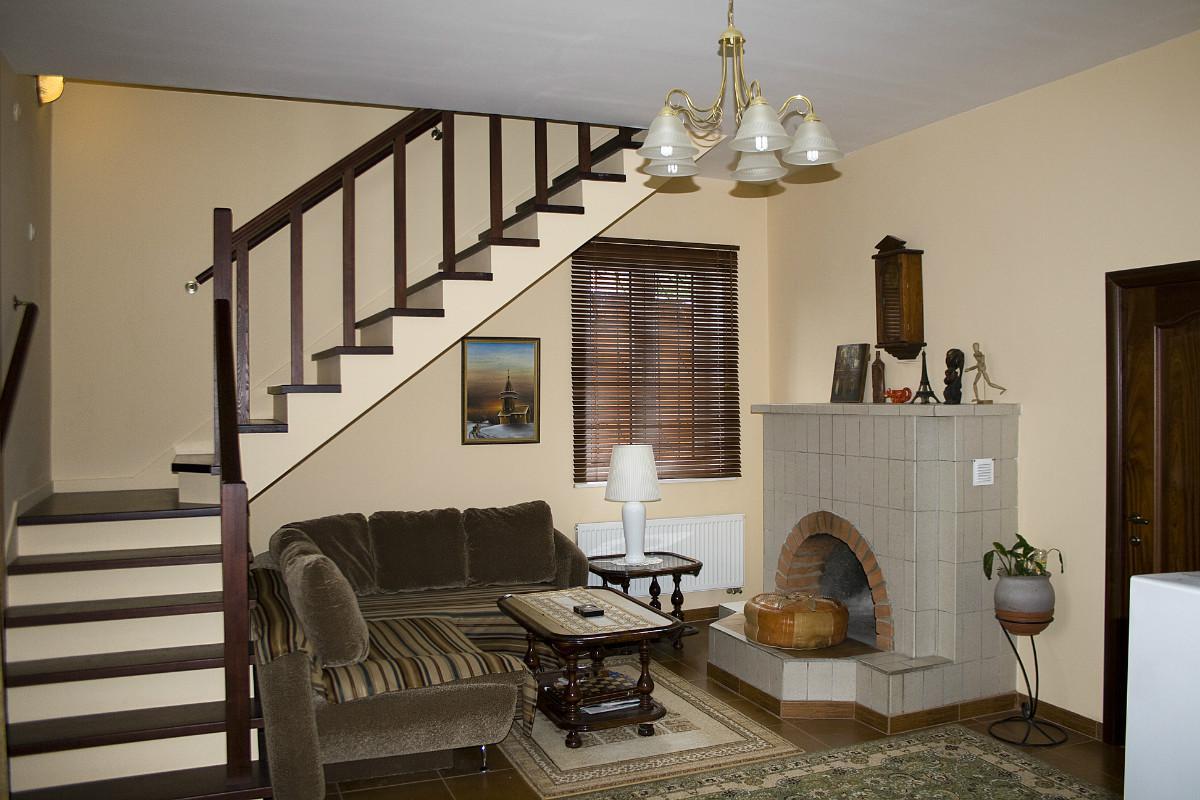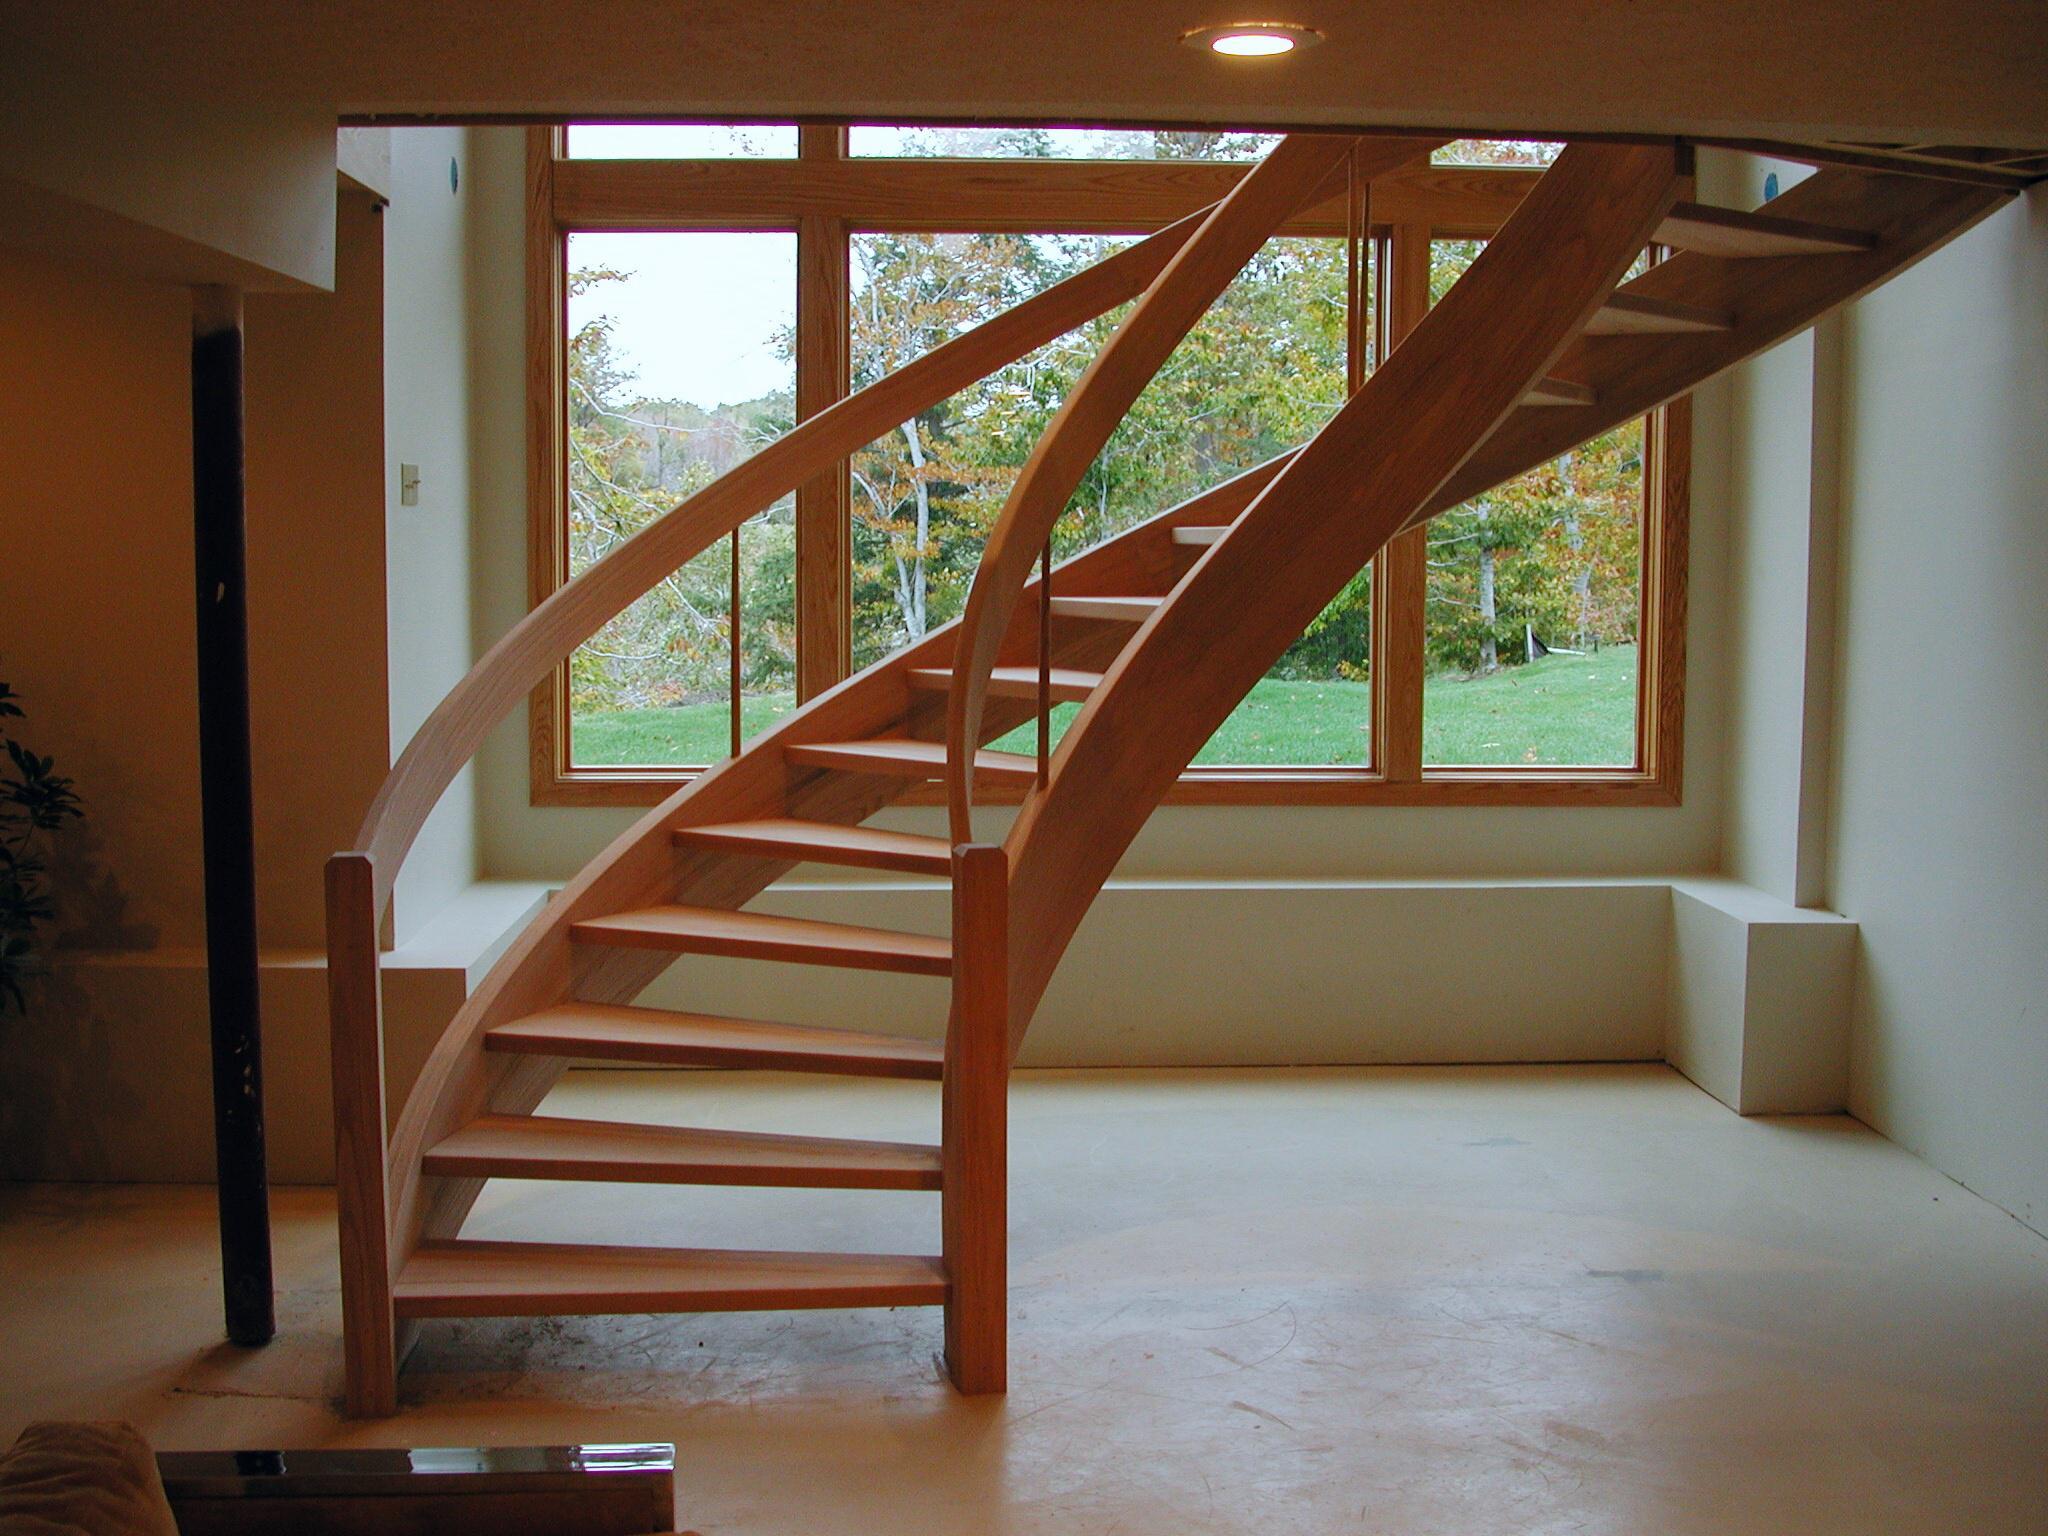The first image is the image on the left, the second image is the image on the right. Analyze the images presented: Is the assertion "The right image features a staircase with a curved wood rail, and the left image features a staircase with a right-angle turn." valid? Answer yes or no. Yes. The first image is the image on the left, the second image is the image on the right. Assess this claim about the two images: "The stairs in the image on the right curve near a large open window.". Correct or not? Answer yes or no. Yes. 